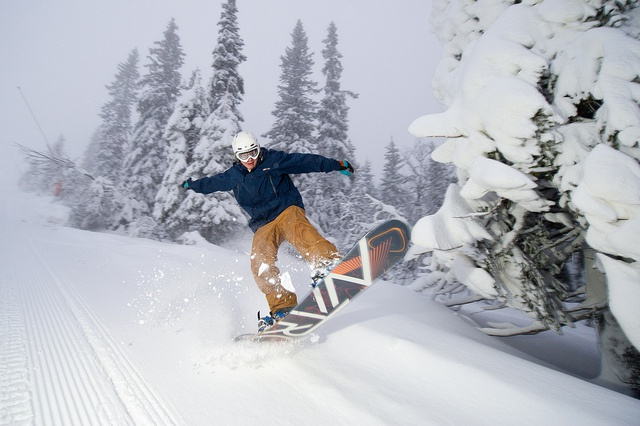Describe the objects in this image and their specific colors. I can see people in lightgray, black, navy, and gray tones and snowboard in lightgray, gray, and darkgray tones in this image. 